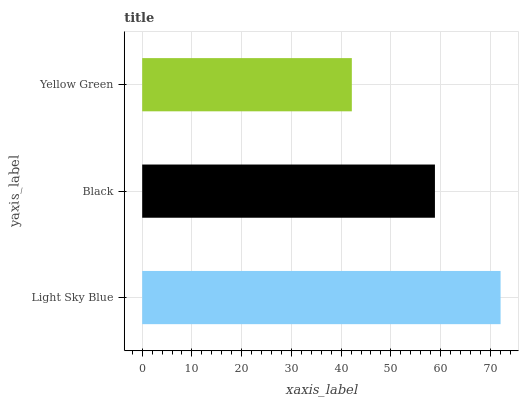Is Yellow Green the minimum?
Answer yes or no. Yes. Is Light Sky Blue the maximum?
Answer yes or no. Yes. Is Black the minimum?
Answer yes or no. No. Is Black the maximum?
Answer yes or no. No. Is Light Sky Blue greater than Black?
Answer yes or no. Yes. Is Black less than Light Sky Blue?
Answer yes or no. Yes. Is Black greater than Light Sky Blue?
Answer yes or no. No. Is Light Sky Blue less than Black?
Answer yes or no. No. Is Black the high median?
Answer yes or no. Yes. Is Black the low median?
Answer yes or no. Yes. Is Yellow Green the high median?
Answer yes or no. No. Is Yellow Green the low median?
Answer yes or no. No. 